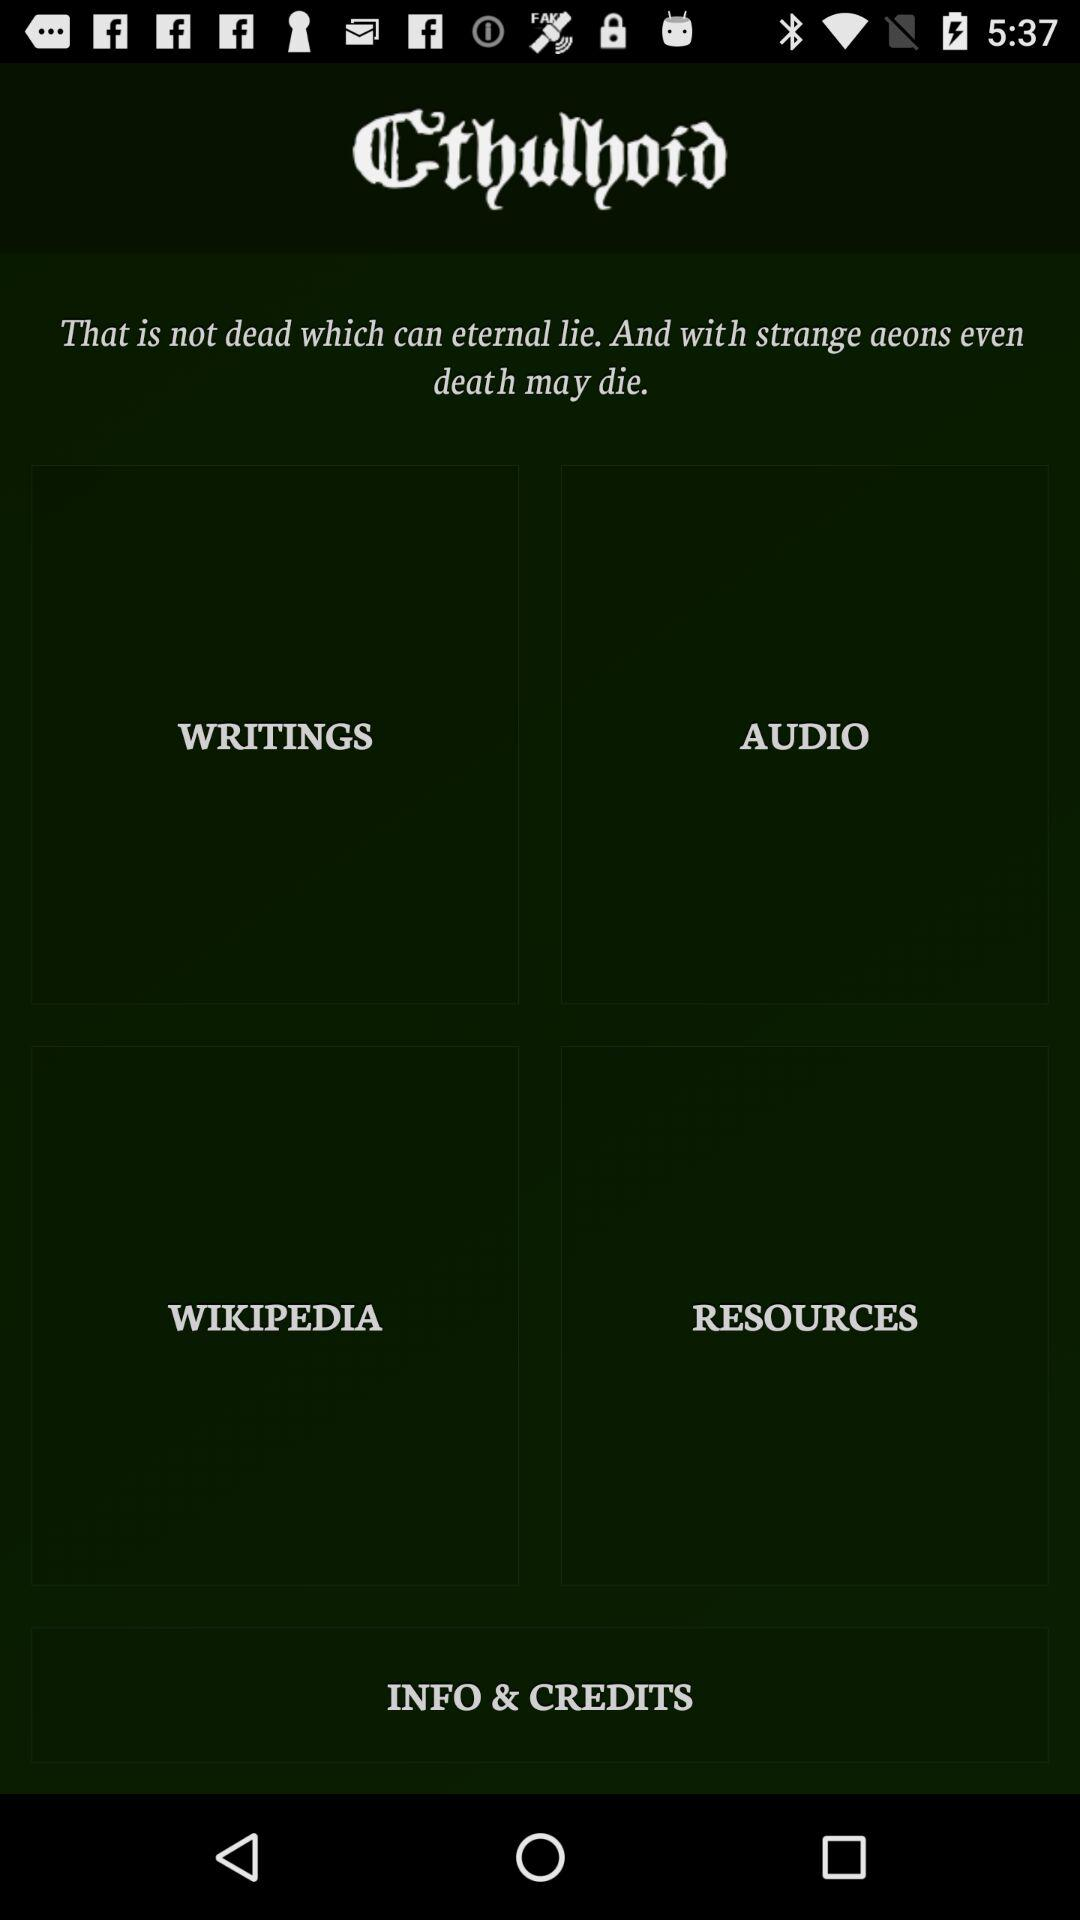What is the application name? The application name is "Cthulhoid". 